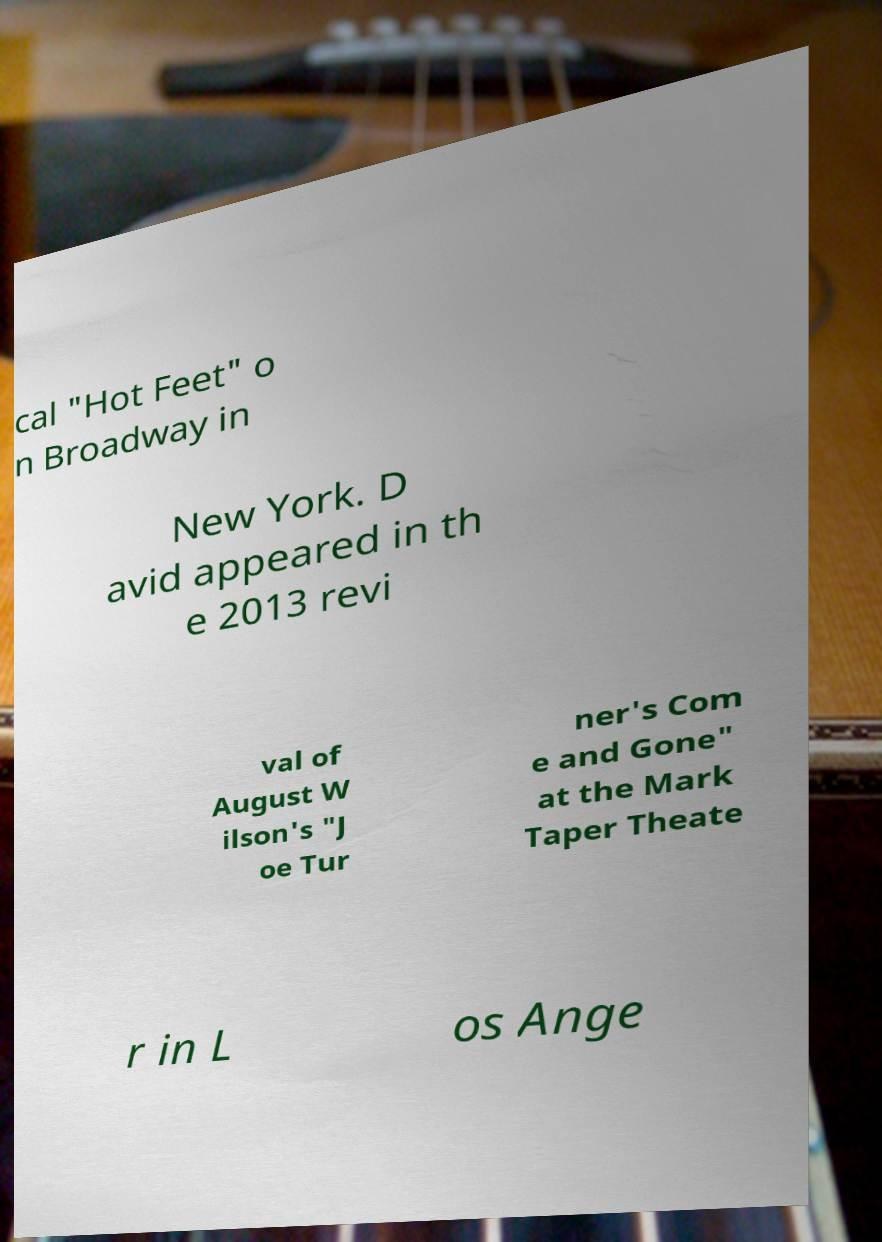What messages or text are displayed in this image? I need them in a readable, typed format. cal "Hot Feet" o n Broadway in New York. D avid appeared in th e 2013 revi val of August W ilson's "J oe Tur ner's Com e and Gone" at the Mark Taper Theate r in L os Ange 